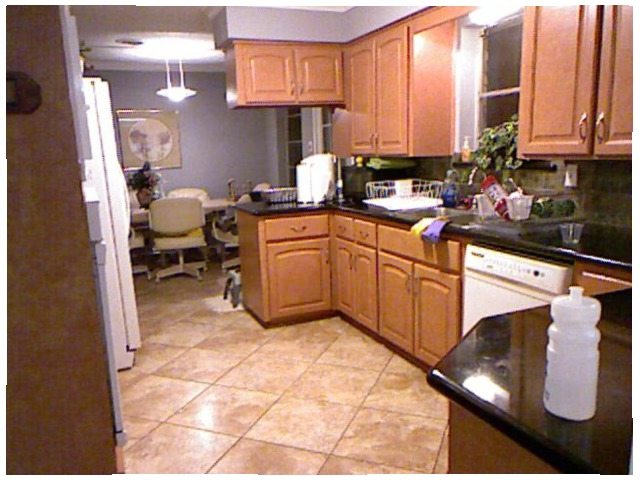<image>
Is there a bottle in the sink? No. The bottle is not contained within the sink. These objects have a different spatial relationship. 